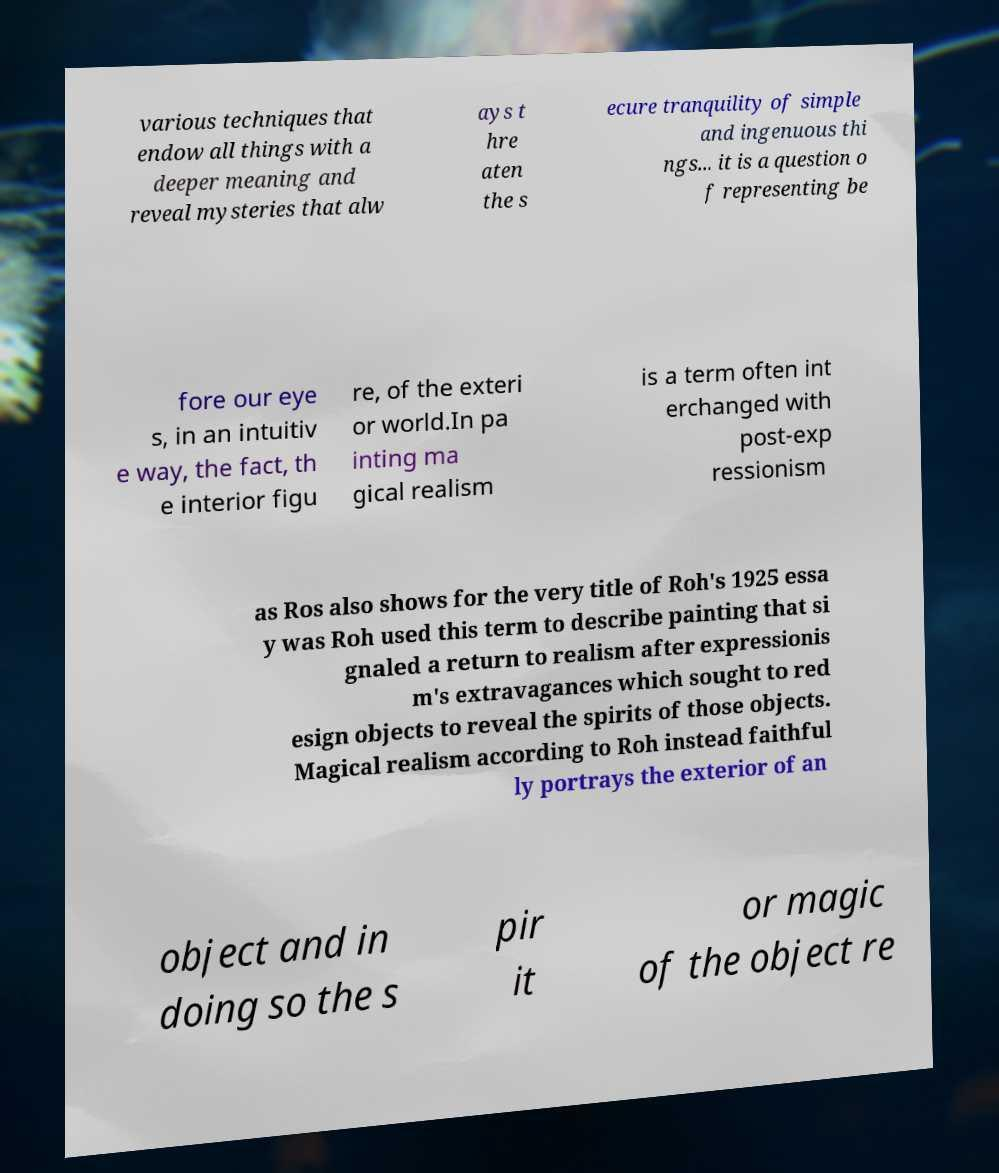Could you extract and type out the text from this image? various techniques that endow all things with a deeper meaning and reveal mysteries that alw ays t hre aten the s ecure tranquility of simple and ingenuous thi ngs... it is a question o f representing be fore our eye s, in an intuitiv e way, the fact, th e interior figu re, of the exteri or world.In pa inting ma gical realism is a term often int erchanged with post-exp ressionism as Ros also shows for the very title of Roh's 1925 essa y was Roh used this term to describe painting that si gnaled a return to realism after expressionis m's extravagances which sought to red esign objects to reveal the spirits of those objects. Magical realism according to Roh instead faithful ly portrays the exterior of an object and in doing so the s pir it or magic of the object re 